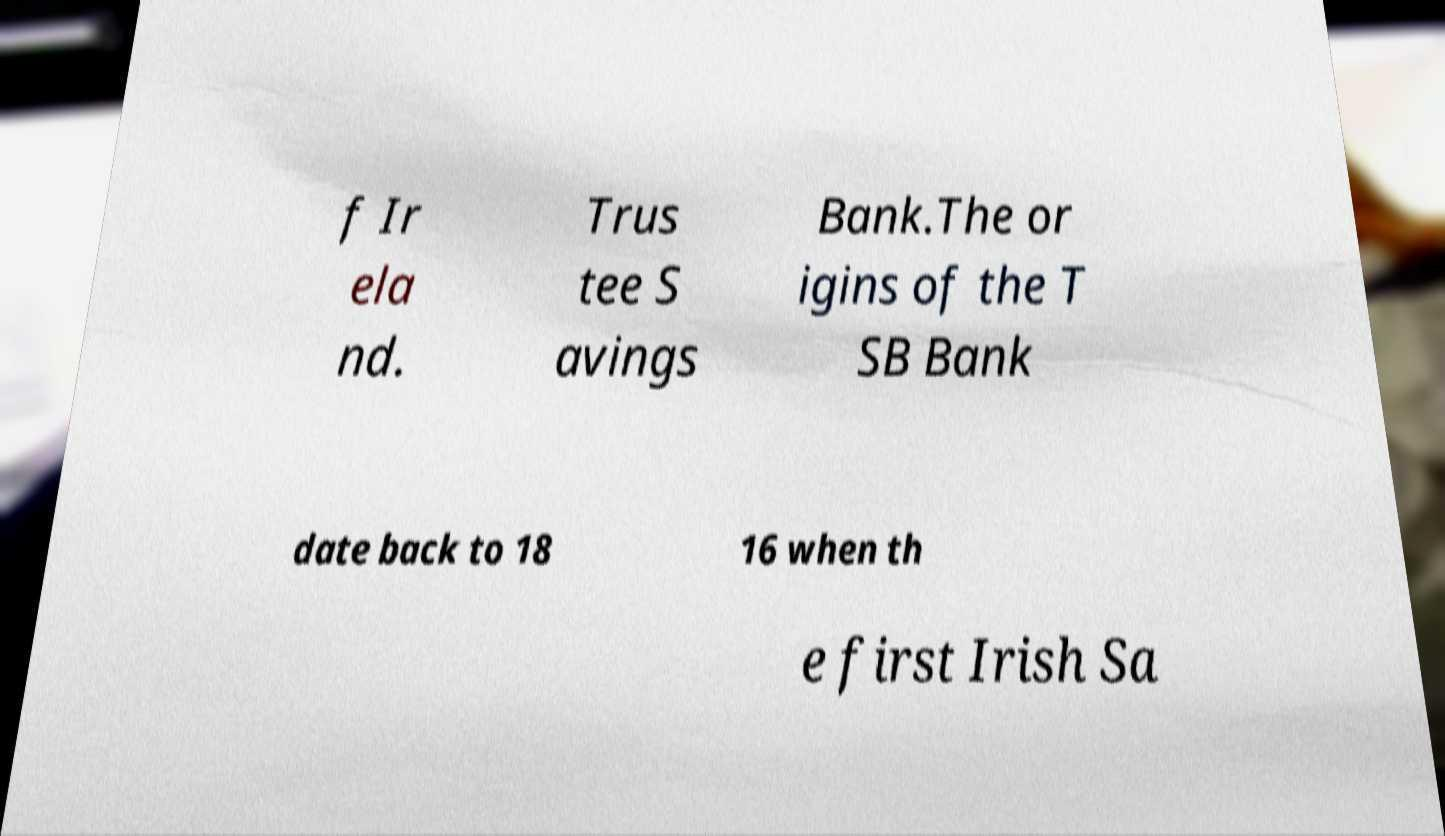For documentation purposes, I need the text within this image transcribed. Could you provide that? f Ir ela nd. Trus tee S avings Bank.The or igins of the T SB Bank date back to 18 16 when th e first Irish Sa 